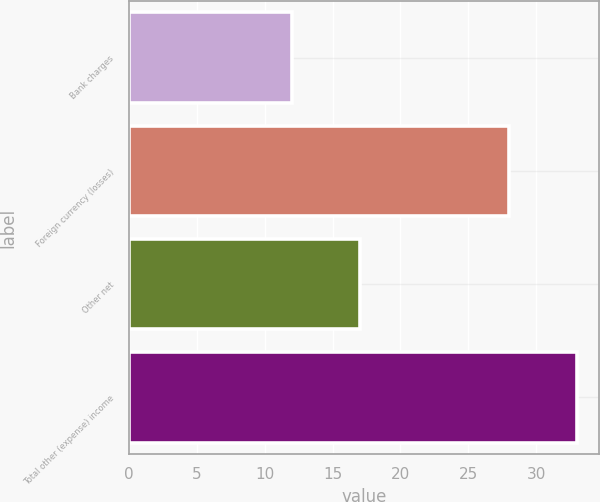<chart> <loc_0><loc_0><loc_500><loc_500><bar_chart><fcel>Bank charges<fcel>Foreign currency (losses)<fcel>Other net<fcel>Total other (expense) income<nl><fcel>12<fcel>28<fcel>17<fcel>33<nl></chart> 